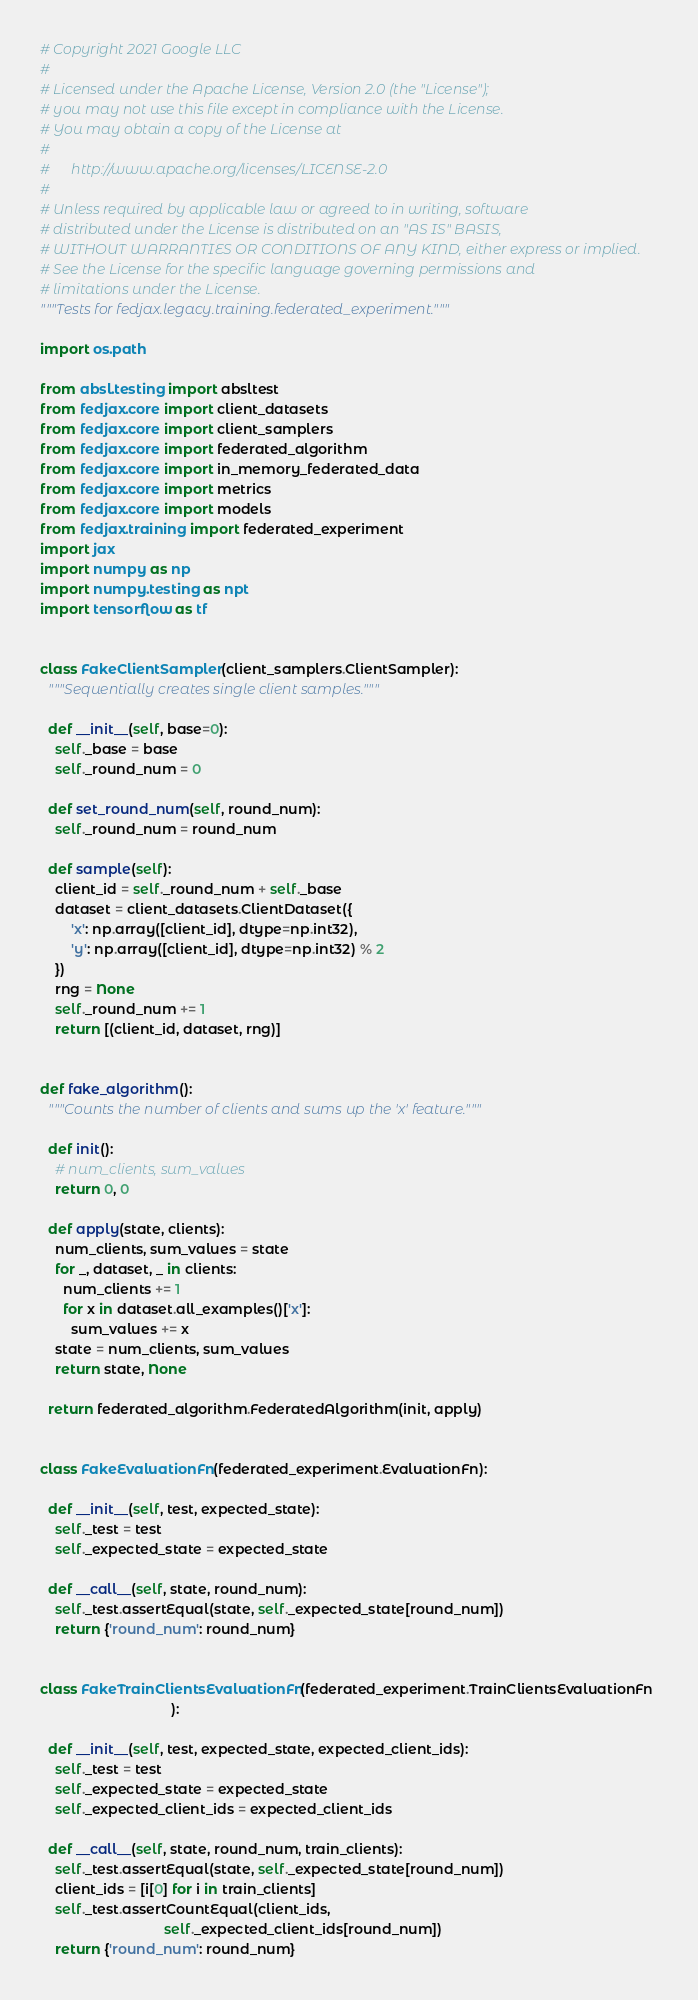Convert code to text. <code><loc_0><loc_0><loc_500><loc_500><_Python_># Copyright 2021 Google LLC
#
# Licensed under the Apache License, Version 2.0 (the "License");
# you may not use this file except in compliance with the License.
# You may obtain a copy of the License at
#
#      http://www.apache.org/licenses/LICENSE-2.0
#
# Unless required by applicable law or agreed to in writing, software
# distributed under the License is distributed on an "AS IS" BASIS,
# WITHOUT WARRANTIES OR CONDITIONS OF ANY KIND, either express or implied.
# See the License for the specific language governing permissions and
# limitations under the License.
"""Tests for fedjax.legacy.training.federated_experiment."""

import os.path

from absl.testing import absltest
from fedjax.core import client_datasets
from fedjax.core import client_samplers
from fedjax.core import federated_algorithm
from fedjax.core import in_memory_federated_data
from fedjax.core import metrics
from fedjax.core import models
from fedjax.training import federated_experiment
import jax
import numpy as np
import numpy.testing as npt
import tensorflow as tf


class FakeClientSampler(client_samplers.ClientSampler):
  """Sequentially creates single client samples."""

  def __init__(self, base=0):
    self._base = base
    self._round_num = 0

  def set_round_num(self, round_num):
    self._round_num = round_num

  def sample(self):
    client_id = self._round_num + self._base
    dataset = client_datasets.ClientDataset({
        'x': np.array([client_id], dtype=np.int32),
        'y': np.array([client_id], dtype=np.int32) % 2
    })
    rng = None
    self._round_num += 1
    return [(client_id, dataset, rng)]


def fake_algorithm():
  """Counts the number of clients and sums up the 'x' feature."""

  def init():
    # num_clients, sum_values
    return 0, 0

  def apply(state, clients):
    num_clients, sum_values = state
    for _, dataset, _ in clients:
      num_clients += 1
      for x in dataset.all_examples()['x']:
        sum_values += x
    state = num_clients, sum_values
    return state, None

  return federated_algorithm.FederatedAlgorithm(init, apply)


class FakeEvaluationFn(federated_experiment.EvaluationFn):

  def __init__(self, test, expected_state):
    self._test = test
    self._expected_state = expected_state

  def __call__(self, state, round_num):
    self._test.assertEqual(state, self._expected_state[round_num])
    return {'round_num': round_num}


class FakeTrainClientsEvaluationFn(federated_experiment.TrainClientsEvaluationFn
                                  ):

  def __init__(self, test, expected_state, expected_client_ids):
    self._test = test
    self._expected_state = expected_state
    self._expected_client_ids = expected_client_ids

  def __call__(self, state, round_num, train_clients):
    self._test.assertEqual(state, self._expected_state[round_num])
    client_ids = [i[0] for i in train_clients]
    self._test.assertCountEqual(client_ids,
                                self._expected_client_ids[round_num])
    return {'round_num': round_num}

</code> 